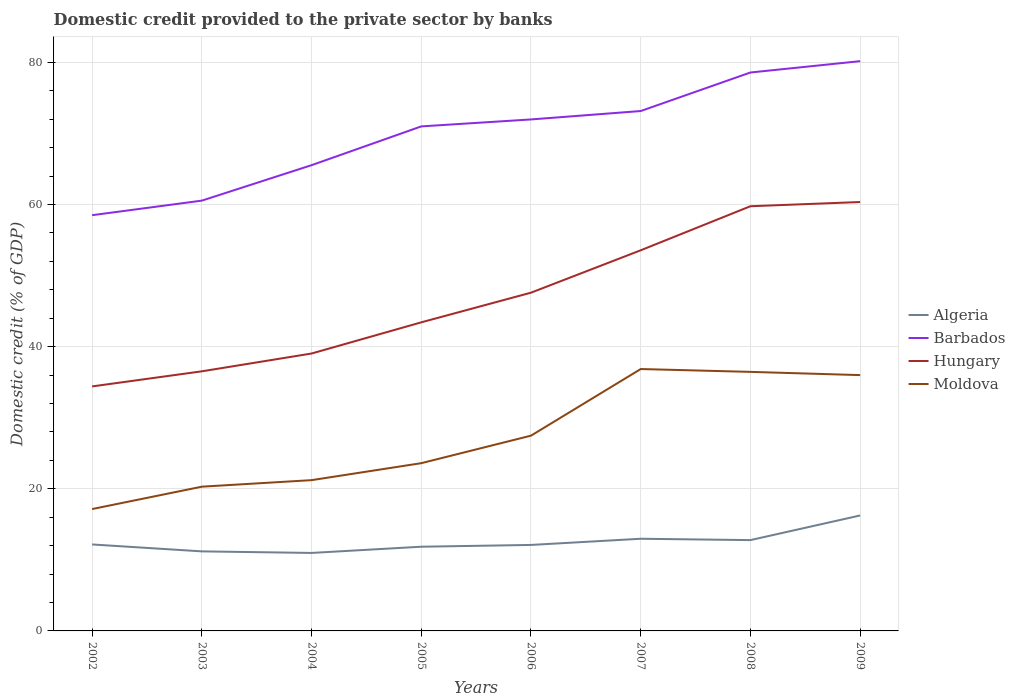How many different coloured lines are there?
Make the answer very short. 4. Across all years, what is the maximum domestic credit provided to the private sector by banks in Barbados?
Keep it short and to the point. 58.49. What is the total domestic credit provided to the private sector by banks in Algeria in the graph?
Your answer should be compact. 0.97. What is the difference between the highest and the second highest domestic credit provided to the private sector by banks in Hungary?
Offer a terse response. 25.94. How many years are there in the graph?
Ensure brevity in your answer.  8. What is the difference between two consecutive major ticks on the Y-axis?
Your answer should be very brief. 20. What is the title of the graph?
Ensure brevity in your answer.  Domestic credit provided to the private sector by banks. Does "Croatia" appear as one of the legend labels in the graph?
Ensure brevity in your answer.  No. What is the label or title of the Y-axis?
Your response must be concise. Domestic credit (% of GDP). What is the Domestic credit (% of GDP) of Algeria in 2002?
Your answer should be very brief. 12.17. What is the Domestic credit (% of GDP) of Barbados in 2002?
Offer a very short reply. 58.49. What is the Domestic credit (% of GDP) of Hungary in 2002?
Your answer should be compact. 34.4. What is the Domestic credit (% of GDP) in Moldova in 2002?
Ensure brevity in your answer.  17.15. What is the Domestic credit (% of GDP) of Algeria in 2003?
Give a very brief answer. 11.19. What is the Domestic credit (% of GDP) of Barbados in 2003?
Your answer should be compact. 60.54. What is the Domestic credit (% of GDP) in Hungary in 2003?
Your answer should be very brief. 36.52. What is the Domestic credit (% of GDP) of Moldova in 2003?
Ensure brevity in your answer.  20.29. What is the Domestic credit (% of GDP) in Algeria in 2004?
Make the answer very short. 10.97. What is the Domestic credit (% of GDP) of Barbados in 2004?
Your response must be concise. 65.53. What is the Domestic credit (% of GDP) of Hungary in 2004?
Your answer should be compact. 39.03. What is the Domestic credit (% of GDP) of Moldova in 2004?
Your answer should be compact. 21.21. What is the Domestic credit (% of GDP) in Algeria in 2005?
Your answer should be compact. 11.85. What is the Domestic credit (% of GDP) in Barbados in 2005?
Your answer should be compact. 70.98. What is the Domestic credit (% of GDP) in Hungary in 2005?
Your answer should be compact. 43.42. What is the Domestic credit (% of GDP) in Moldova in 2005?
Your answer should be compact. 23.6. What is the Domestic credit (% of GDP) in Algeria in 2006?
Provide a succinct answer. 12.1. What is the Domestic credit (% of GDP) of Barbados in 2006?
Provide a succinct answer. 71.96. What is the Domestic credit (% of GDP) of Hungary in 2006?
Provide a short and direct response. 47.59. What is the Domestic credit (% of GDP) in Moldova in 2006?
Provide a succinct answer. 27.47. What is the Domestic credit (% of GDP) in Algeria in 2007?
Your answer should be compact. 12.97. What is the Domestic credit (% of GDP) in Barbados in 2007?
Make the answer very short. 73.15. What is the Domestic credit (% of GDP) of Hungary in 2007?
Give a very brief answer. 53.55. What is the Domestic credit (% of GDP) of Moldova in 2007?
Offer a very short reply. 36.85. What is the Domestic credit (% of GDP) of Algeria in 2008?
Keep it short and to the point. 12.78. What is the Domestic credit (% of GDP) of Barbados in 2008?
Ensure brevity in your answer.  78.57. What is the Domestic credit (% of GDP) of Hungary in 2008?
Your answer should be very brief. 59.75. What is the Domestic credit (% of GDP) of Moldova in 2008?
Keep it short and to the point. 36.45. What is the Domestic credit (% of GDP) in Algeria in 2009?
Provide a short and direct response. 16.25. What is the Domestic credit (% of GDP) in Barbados in 2009?
Ensure brevity in your answer.  80.16. What is the Domestic credit (% of GDP) of Hungary in 2009?
Keep it short and to the point. 60.34. What is the Domestic credit (% of GDP) in Moldova in 2009?
Provide a succinct answer. 35.99. Across all years, what is the maximum Domestic credit (% of GDP) of Algeria?
Offer a terse response. 16.25. Across all years, what is the maximum Domestic credit (% of GDP) of Barbados?
Give a very brief answer. 80.16. Across all years, what is the maximum Domestic credit (% of GDP) in Hungary?
Provide a succinct answer. 60.34. Across all years, what is the maximum Domestic credit (% of GDP) of Moldova?
Ensure brevity in your answer.  36.85. Across all years, what is the minimum Domestic credit (% of GDP) of Algeria?
Your answer should be very brief. 10.97. Across all years, what is the minimum Domestic credit (% of GDP) of Barbados?
Offer a very short reply. 58.49. Across all years, what is the minimum Domestic credit (% of GDP) in Hungary?
Your answer should be compact. 34.4. Across all years, what is the minimum Domestic credit (% of GDP) in Moldova?
Your answer should be compact. 17.15. What is the total Domestic credit (% of GDP) in Algeria in the graph?
Your answer should be compact. 100.26. What is the total Domestic credit (% of GDP) of Barbados in the graph?
Ensure brevity in your answer.  559.38. What is the total Domestic credit (% of GDP) of Hungary in the graph?
Provide a succinct answer. 374.61. What is the total Domestic credit (% of GDP) in Moldova in the graph?
Your response must be concise. 219.01. What is the difference between the Domestic credit (% of GDP) of Algeria in 2002 and that in 2003?
Offer a very short reply. 0.97. What is the difference between the Domestic credit (% of GDP) of Barbados in 2002 and that in 2003?
Your response must be concise. -2.05. What is the difference between the Domestic credit (% of GDP) of Hungary in 2002 and that in 2003?
Provide a succinct answer. -2.12. What is the difference between the Domestic credit (% of GDP) in Moldova in 2002 and that in 2003?
Provide a short and direct response. -3.15. What is the difference between the Domestic credit (% of GDP) in Algeria in 2002 and that in 2004?
Your answer should be very brief. 1.19. What is the difference between the Domestic credit (% of GDP) of Barbados in 2002 and that in 2004?
Provide a short and direct response. -7.04. What is the difference between the Domestic credit (% of GDP) of Hungary in 2002 and that in 2004?
Offer a very short reply. -4.63. What is the difference between the Domestic credit (% of GDP) in Moldova in 2002 and that in 2004?
Your answer should be very brief. -4.07. What is the difference between the Domestic credit (% of GDP) in Algeria in 2002 and that in 2005?
Your response must be concise. 0.32. What is the difference between the Domestic credit (% of GDP) in Barbados in 2002 and that in 2005?
Keep it short and to the point. -12.49. What is the difference between the Domestic credit (% of GDP) of Hungary in 2002 and that in 2005?
Make the answer very short. -9.02. What is the difference between the Domestic credit (% of GDP) of Moldova in 2002 and that in 2005?
Keep it short and to the point. -6.46. What is the difference between the Domestic credit (% of GDP) of Algeria in 2002 and that in 2006?
Offer a very short reply. 0.07. What is the difference between the Domestic credit (% of GDP) of Barbados in 2002 and that in 2006?
Your answer should be compact. -13.47. What is the difference between the Domestic credit (% of GDP) in Hungary in 2002 and that in 2006?
Your response must be concise. -13.19. What is the difference between the Domestic credit (% of GDP) in Moldova in 2002 and that in 2006?
Provide a succinct answer. -10.33. What is the difference between the Domestic credit (% of GDP) in Algeria in 2002 and that in 2007?
Offer a terse response. -0.8. What is the difference between the Domestic credit (% of GDP) in Barbados in 2002 and that in 2007?
Make the answer very short. -14.65. What is the difference between the Domestic credit (% of GDP) in Hungary in 2002 and that in 2007?
Your answer should be very brief. -19.15. What is the difference between the Domestic credit (% of GDP) in Moldova in 2002 and that in 2007?
Offer a terse response. -19.7. What is the difference between the Domestic credit (% of GDP) of Algeria in 2002 and that in 2008?
Offer a very short reply. -0.61. What is the difference between the Domestic credit (% of GDP) of Barbados in 2002 and that in 2008?
Your answer should be very brief. -20.08. What is the difference between the Domestic credit (% of GDP) in Hungary in 2002 and that in 2008?
Offer a terse response. -25.35. What is the difference between the Domestic credit (% of GDP) of Moldova in 2002 and that in 2008?
Offer a very short reply. -19.3. What is the difference between the Domestic credit (% of GDP) in Algeria in 2002 and that in 2009?
Keep it short and to the point. -4.08. What is the difference between the Domestic credit (% of GDP) of Barbados in 2002 and that in 2009?
Give a very brief answer. -21.67. What is the difference between the Domestic credit (% of GDP) of Hungary in 2002 and that in 2009?
Provide a succinct answer. -25.94. What is the difference between the Domestic credit (% of GDP) in Moldova in 2002 and that in 2009?
Your answer should be very brief. -18.84. What is the difference between the Domestic credit (% of GDP) in Algeria in 2003 and that in 2004?
Make the answer very short. 0.22. What is the difference between the Domestic credit (% of GDP) of Barbados in 2003 and that in 2004?
Ensure brevity in your answer.  -4.99. What is the difference between the Domestic credit (% of GDP) in Hungary in 2003 and that in 2004?
Your answer should be compact. -2.5. What is the difference between the Domestic credit (% of GDP) in Moldova in 2003 and that in 2004?
Your answer should be very brief. -0.92. What is the difference between the Domestic credit (% of GDP) of Algeria in 2003 and that in 2005?
Make the answer very short. -0.66. What is the difference between the Domestic credit (% of GDP) of Barbados in 2003 and that in 2005?
Ensure brevity in your answer.  -10.44. What is the difference between the Domestic credit (% of GDP) of Hungary in 2003 and that in 2005?
Your answer should be very brief. -6.89. What is the difference between the Domestic credit (% of GDP) of Moldova in 2003 and that in 2005?
Give a very brief answer. -3.31. What is the difference between the Domestic credit (% of GDP) in Algeria in 2003 and that in 2006?
Your response must be concise. -0.91. What is the difference between the Domestic credit (% of GDP) in Barbados in 2003 and that in 2006?
Make the answer very short. -11.42. What is the difference between the Domestic credit (% of GDP) of Hungary in 2003 and that in 2006?
Provide a short and direct response. -11.07. What is the difference between the Domestic credit (% of GDP) of Moldova in 2003 and that in 2006?
Your answer should be compact. -7.18. What is the difference between the Domestic credit (% of GDP) of Algeria in 2003 and that in 2007?
Your response must be concise. -1.78. What is the difference between the Domestic credit (% of GDP) of Barbados in 2003 and that in 2007?
Keep it short and to the point. -12.61. What is the difference between the Domestic credit (% of GDP) of Hungary in 2003 and that in 2007?
Offer a very short reply. -17.03. What is the difference between the Domestic credit (% of GDP) in Moldova in 2003 and that in 2007?
Your answer should be very brief. -16.55. What is the difference between the Domestic credit (% of GDP) of Algeria in 2003 and that in 2008?
Your answer should be very brief. -1.59. What is the difference between the Domestic credit (% of GDP) in Barbados in 2003 and that in 2008?
Make the answer very short. -18.03. What is the difference between the Domestic credit (% of GDP) in Hungary in 2003 and that in 2008?
Keep it short and to the point. -23.23. What is the difference between the Domestic credit (% of GDP) of Moldova in 2003 and that in 2008?
Your answer should be very brief. -16.15. What is the difference between the Domestic credit (% of GDP) in Algeria in 2003 and that in 2009?
Keep it short and to the point. -5.05. What is the difference between the Domestic credit (% of GDP) of Barbados in 2003 and that in 2009?
Offer a very short reply. -19.62. What is the difference between the Domestic credit (% of GDP) in Hungary in 2003 and that in 2009?
Offer a terse response. -23.82. What is the difference between the Domestic credit (% of GDP) of Moldova in 2003 and that in 2009?
Make the answer very short. -15.7. What is the difference between the Domestic credit (% of GDP) in Algeria in 2004 and that in 2005?
Offer a very short reply. -0.87. What is the difference between the Domestic credit (% of GDP) of Barbados in 2004 and that in 2005?
Provide a succinct answer. -5.46. What is the difference between the Domestic credit (% of GDP) of Hungary in 2004 and that in 2005?
Offer a very short reply. -4.39. What is the difference between the Domestic credit (% of GDP) of Moldova in 2004 and that in 2005?
Keep it short and to the point. -2.39. What is the difference between the Domestic credit (% of GDP) in Algeria in 2004 and that in 2006?
Keep it short and to the point. -1.12. What is the difference between the Domestic credit (% of GDP) of Barbados in 2004 and that in 2006?
Your answer should be compact. -6.44. What is the difference between the Domestic credit (% of GDP) of Hungary in 2004 and that in 2006?
Make the answer very short. -8.56. What is the difference between the Domestic credit (% of GDP) in Moldova in 2004 and that in 2006?
Provide a succinct answer. -6.26. What is the difference between the Domestic credit (% of GDP) in Algeria in 2004 and that in 2007?
Your response must be concise. -2. What is the difference between the Domestic credit (% of GDP) of Barbados in 2004 and that in 2007?
Your response must be concise. -7.62. What is the difference between the Domestic credit (% of GDP) in Hungary in 2004 and that in 2007?
Keep it short and to the point. -14.52. What is the difference between the Domestic credit (% of GDP) in Moldova in 2004 and that in 2007?
Ensure brevity in your answer.  -15.63. What is the difference between the Domestic credit (% of GDP) of Algeria in 2004 and that in 2008?
Offer a terse response. -1.8. What is the difference between the Domestic credit (% of GDP) of Barbados in 2004 and that in 2008?
Your response must be concise. -13.04. What is the difference between the Domestic credit (% of GDP) in Hungary in 2004 and that in 2008?
Offer a very short reply. -20.72. What is the difference between the Domestic credit (% of GDP) of Moldova in 2004 and that in 2008?
Your response must be concise. -15.23. What is the difference between the Domestic credit (% of GDP) of Algeria in 2004 and that in 2009?
Offer a terse response. -5.27. What is the difference between the Domestic credit (% of GDP) in Barbados in 2004 and that in 2009?
Provide a short and direct response. -14.63. What is the difference between the Domestic credit (% of GDP) in Hungary in 2004 and that in 2009?
Make the answer very short. -21.31. What is the difference between the Domestic credit (% of GDP) in Moldova in 2004 and that in 2009?
Your answer should be compact. -14.78. What is the difference between the Domestic credit (% of GDP) of Algeria in 2005 and that in 2006?
Make the answer very short. -0.25. What is the difference between the Domestic credit (% of GDP) of Barbados in 2005 and that in 2006?
Make the answer very short. -0.98. What is the difference between the Domestic credit (% of GDP) in Hungary in 2005 and that in 2006?
Your answer should be very brief. -4.17. What is the difference between the Domestic credit (% of GDP) in Moldova in 2005 and that in 2006?
Your answer should be very brief. -3.87. What is the difference between the Domestic credit (% of GDP) of Algeria in 2005 and that in 2007?
Your response must be concise. -1.12. What is the difference between the Domestic credit (% of GDP) in Barbados in 2005 and that in 2007?
Offer a terse response. -2.16. What is the difference between the Domestic credit (% of GDP) in Hungary in 2005 and that in 2007?
Offer a very short reply. -10.14. What is the difference between the Domestic credit (% of GDP) in Moldova in 2005 and that in 2007?
Make the answer very short. -13.24. What is the difference between the Domestic credit (% of GDP) of Algeria in 2005 and that in 2008?
Offer a very short reply. -0.93. What is the difference between the Domestic credit (% of GDP) in Barbados in 2005 and that in 2008?
Your answer should be compact. -7.58. What is the difference between the Domestic credit (% of GDP) of Hungary in 2005 and that in 2008?
Your response must be concise. -16.33. What is the difference between the Domestic credit (% of GDP) in Moldova in 2005 and that in 2008?
Make the answer very short. -12.85. What is the difference between the Domestic credit (% of GDP) of Algeria in 2005 and that in 2009?
Your answer should be very brief. -4.4. What is the difference between the Domestic credit (% of GDP) of Barbados in 2005 and that in 2009?
Your response must be concise. -9.18. What is the difference between the Domestic credit (% of GDP) of Hungary in 2005 and that in 2009?
Ensure brevity in your answer.  -16.93. What is the difference between the Domestic credit (% of GDP) of Moldova in 2005 and that in 2009?
Provide a succinct answer. -12.39. What is the difference between the Domestic credit (% of GDP) in Algeria in 2006 and that in 2007?
Make the answer very short. -0.87. What is the difference between the Domestic credit (% of GDP) of Barbados in 2006 and that in 2007?
Provide a short and direct response. -1.18. What is the difference between the Domestic credit (% of GDP) in Hungary in 2006 and that in 2007?
Your answer should be compact. -5.96. What is the difference between the Domestic credit (% of GDP) of Moldova in 2006 and that in 2007?
Keep it short and to the point. -9.37. What is the difference between the Domestic credit (% of GDP) of Algeria in 2006 and that in 2008?
Keep it short and to the point. -0.68. What is the difference between the Domestic credit (% of GDP) of Barbados in 2006 and that in 2008?
Keep it short and to the point. -6.6. What is the difference between the Domestic credit (% of GDP) of Hungary in 2006 and that in 2008?
Ensure brevity in your answer.  -12.16. What is the difference between the Domestic credit (% of GDP) in Moldova in 2006 and that in 2008?
Ensure brevity in your answer.  -8.97. What is the difference between the Domestic credit (% of GDP) in Algeria in 2006 and that in 2009?
Keep it short and to the point. -4.15. What is the difference between the Domestic credit (% of GDP) of Barbados in 2006 and that in 2009?
Provide a succinct answer. -8.2. What is the difference between the Domestic credit (% of GDP) in Hungary in 2006 and that in 2009?
Offer a very short reply. -12.75. What is the difference between the Domestic credit (% of GDP) of Moldova in 2006 and that in 2009?
Offer a terse response. -8.52. What is the difference between the Domestic credit (% of GDP) in Algeria in 2007 and that in 2008?
Your answer should be very brief. 0.19. What is the difference between the Domestic credit (% of GDP) in Barbados in 2007 and that in 2008?
Provide a succinct answer. -5.42. What is the difference between the Domestic credit (% of GDP) in Hungary in 2007 and that in 2008?
Give a very brief answer. -6.2. What is the difference between the Domestic credit (% of GDP) in Moldova in 2007 and that in 2008?
Ensure brevity in your answer.  0.4. What is the difference between the Domestic credit (% of GDP) in Algeria in 2007 and that in 2009?
Make the answer very short. -3.28. What is the difference between the Domestic credit (% of GDP) in Barbados in 2007 and that in 2009?
Provide a short and direct response. -7.02. What is the difference between the Domestic credit (% of GDP) of Hungary in 2007 and that in 2009?
Your answer should be compact. -6.79. What is the difference between the Domestic credit (% of GDP) of Moldova in 2007 and that in 2009?
Give a very brief answer. 0.85. What is the difference between the Domestic credit (% of GDP) of Algeria in 2008 and that in 2009?
Offer a terse response. -3.47. What is the difference between the Domestic credit (% of GDP) in Barbados in 2008 and that in 2009?
Offer a very short reply. -1.59. What is the difference between the Domestic credit (% of GDP) in Hungary in 2008 and that in 2009?
Offer a very short reply. -0.59. What is the difference between the Domestic credit (% of GDP) in Moldova in 2008 and that in 2009?
Provide a succinct answer. 0.46. What is the difference between the Domestic credit (% of GDP) in Algeria in 2002 and the Domestic credit (% of GDP) in Barbados in 2003?
Give a very brief answer. -48.37. What is the difference between the Domestic credit (% of GDP) of Algeria in 2002 and the Domestic credit (% of GDP) of Hungary in 2003?
Your response must be concise. -24.36. What is the difference between the Domestic credit (% of GDP) in Algeria in 2002 and the Domestic credit (% of GDP) in Moldova in 2003?
Your response must be concise. -8.13. What is the difference between the Domestic credit (% of GDP) in Barbados in 2002 and the Domestic credit (% of GDP) in Hungary in 2003?
Keep it short and to the point. 21.97. What is the difference between the Domestic credit (% of GDP) of Barbados in 2002 and the Domestic credit (% of GDP) of Moldova in 2003?
Your response must be concise. 38.2. What is the difference between the Domestic credit (% of GDP) in Hungary in 2002 and the Domestic credit (% of GDP) in Moldova in 2003?
Make the answer very short. 14.11. What is the difference between the Domestic credit (% of GDP) of Algeria in 2002 and the Domestic credit (% of GDP) of Barbados in 2004?
Offer a terse response. -53.36. What is the difference between the Domestic credit (% of GDP) in Algeria in 2002 and the Domestic credit (% of GDP) in Hungary in 2004?
Keep it short and to the point. -26.86. What is the difference between the Domestic credit (% of GDP) of Algeria in 2002 and the Domestic credit (% of GDP) of Moldova in 2004?
Make the answer very short. -9.05. What is the difference between the Domestic credit (% of GDP) of Barbados in 2002 and the Domestic credit (% of GDP) of Hungary in 2004?
Provide a short and direct response. 19.46. What is the difference between the Domestic credit (% of GDP) of Barbados in 2002 and the Domestic credit (% of GDP) of Moldova in 2004?
Give a very brief answer. 37.28. What is the difference between the Domestic credit (% of GDP) of Hungary in 2002 and the Domestic credit (% of GDP) of Moldova in 2004?
Your answer should be compact. 13.19. What is the difference between the Domestic credit (% of GDP) of Algeria in 2002 and the Domestic credit (% of GDP) of Barbados in 2005?
Give a very brief answer. -58.82. What is the difference between the Domestic credit (% of GDP) in Algeria in 2002 and the Domestic credit (% of GDP) in Hungary in 2005?
Ensure brevity in your answer.  -31.25. What is the difference between the Domestic credit (% of GDP) in Algeria in 2002 and the Domestic credit (% of GDP) in Moldova in 2005?
Your answer should be very brief. -11.44. What is the difference between the Domestic credit (% of GDP) of Barbados in 2002 and the Domestic credit (% of GDP) of Hungary in 2005?
Offer a very short reply. 15.07. What is the difference between the Domestic credit (% of GDP) of Barbados in 2002 and the Domestic credit (% of GDP) of Moldova in 2005?
Offer a terse response. 34.89. What is the difference between the Domestic credit (% of GDP) of Hungary in 2002 and the Domestic credit (% of GDP) of Moldova in 2005?
Your response must be concise. 10.8. What is the difference between the Domestic credit (% of GDP) in Algeria in 2002 and the Domestic credit (% of GDP) in Barbados in 2006?
Your response must be concise. -59.8. What is the difference between the Domestic credit (% of GDP) of Algeria in 2002 and the Domestic credit (% of GDP) of Hungary in 2006?
Offer a very short reply. -35.42. What is the difference between the Domestic credit (% of GDP) of Algeria in 2002 and the Domestic credit (% of GDP) of Moldova in 2006?
Keep it short and to the point. -15.31. What is the difference between the Domestic credit (% of GDP) in Barbados in 2002 and the Domestic credit (% of GDP) in Hungary in 2006?
Provide a succinct answer. 10.9. What is the difference between the Domestic credit (% of GDP) in Barbados in 2002 and the Domestic credit (% of GDP) in Moldova in 2006?
Give a very brief answer. 31.02. What is the difference between the Domestic credit (% of GDP) of Hungary in 2002 and the Domestic credit (% of GDP) of Moldova in 2006?
Ensure brevity in your answer.  6.93. What is the difference between the Domestic credit (% of GDP) in Algeria in 2002 and the Domestic credit (% of GDP) in Barbados in 2007?
Make the answer very short. -60.98. What is the difference between the Domestic credit (% of GDP) of Algeria in 2002 and the Domestic credit (% of GDP) of Hungary in 2007?
Your answer should be compact. -41.39. What is the difference between the Domestic credit (% of GDP) in Algeria in 2002 and the Domestic credit (% of GDP) in Moldova in 2007?
Your answer should be very brief. -24.68. What is the difference between the Domestic credit (% of GDP) in Barbados in 2002 and the Domestic credit (% of GDP) in Hungary in 2007?
Ensure brevity in your answer.  4.94. What is the difference between the Domestic credit (% of GDP) in Barbados in 2002 and the Domestic credit (% of GDP) in Moldova in 2007?
Offer a terse response. 21.65. What is the difference between the Domestic credit (% of GDP) in Hungary in 2002 and the Domestic credit (% of GDP) in Moldova in 2007?
Your answer should be very brief. -2.44. What is the difference between the Domestic credit (% of GDP) of Algeria in 2002 and the Domestic credit (% of GDP) of Barbados in 2008?
Your answer should be very brief. -66.4. What is the difference between the Domestic credit (% of GDP) in Algeria in 2002 and the Domestic credit (% of GDP) in Hungary in 2008?
Keep it short and to the point. -47.59. What is the difference between the Domestic credit (% of GDP) of Algeria in 2002 and the Domestic credit (% of GDP) of Moldova in 2008?
Offer a very short reply. -24.28. What is the difference between the Domestic credit (% of GDP) in Barbados in 2002 and the Domestic credit (% of GDP) in Hungary in 2008?
Your answer should be very brief. -1.26. What is the difference between the Domestic credit (% of GDP) of Barbados in 2002 and the Domestic credit (% of GDP) of Moldova in 2008?
Offer a terse response. 22.04. What is the difference between the Domestic credit (% of GDP) in Hungary in 2002 and the Domestic credit (% of GDP) in Moldova in 2008?
Provide a succinct answer. -2.05. What is the difference between the Domestic credit (% of GDP) of Algeria in 2002 and the Domestic credit (% of GDP) of Barbados in 2009?
Give a very brief answer. -68. What is the difference between the Domestic credit (% of GDP) of Algeria in 2002 and the Domestic credit (% of GDP) of Hungary in 2009?
Your response must be concise. -48.18. What is the difference between the Domestic credit (% of GDP) of Algeria in 2002 and the Domestic credit (% of GDP) of Moldova in 2009?
Ensure brevity in your answer.  -23.83. What is the difference between the Domestic credit (% of GDP) of Barbados in 2002 and the Domestic credit (% of GDP) of Hungary in 2009?
Keep it short and to the point. -1.85. What is the difference between the Domestic credit (% of GDP) of Barbados in 2002 and the Domestic credit (% of GDP) of Moldova in 2009?
Give a very brief answer. 22.5. What is the difference between the Domestic credit (% of GDP) of Hungary in 2002 and the Domestic credit (% of GDP) of Moldova in 2009?
Provide a succinct answer. -1.59. What is the difference between the Domestic credit (% of GDP) of Algeria in 2003 and the Domestic credit (% of GDP) of Barbados in 2004?
Your answer should be very brief. -54.34. What is the difference between the Domestic credit (% of GDP) in Algeria in 2003 and the Domestic credit (% of GDP) in Hungary in 2004?
Your answer should be very brief. -27.84. What is the difference between the Domestic credit (% of GDP) in Algeria in 2003 and the Domestic credit (% of GDP) in Moldova in 2004?
Your answer should be compact. -10.02. What is the difference between the Domestic credit (% of GDP) of Barbados in 2003 and the Domestic credit (% of GDP) of Hungary in 2004?
Offer a very short reply. 21.51. What is the difference between the Domestic credit (% of GDP) of Barbados in 2003 and the Domestic credit (% of GDP) of Moldova in 2004?
Offer a very short reply. 39.33. What is the difference between the Domestic credit (% of GDP) of Hungary in 2003 and the Domestic credit (% of GDP) of Moldova in 2004?
Offer a terse response. 15.31. What is the difference between the Domestic credit (% of GDP) in Algeria in 2003 and the Domestic credit (% of GDP) in Barbados in 2005?
Provide a short and direct response. -59.79. What is the difference between the Domestic credit (% of GDP) in Algeria in 2003 and the Domestic credit (% of GDP) in Hungary in 2005?
Make the answer very short. -32.23. What is the difference between the Domestic credit (% of GDP) in Algeria in 2003 and the Domestic credit (% of GDP) in Moldova in 2005?
Offer a terse response. -12.41. What is the difference between the Domestic credit (% of GDP) of Barbados in 2003 and the Domestic credit (% of GDP) of Hungary in 2005?
Offer a terse response. 17.12. What is the difference between the Domestic credit (% of GDP) of Barbados in 2003 and the Domestic credit (% of GDP) of Moldova in 2005?
Your response must be concise. 36.94. What is the difference between the Domestic credit (% of GDP) of Hungary in 2003 and the Domestic credit (% of GDP) of Moldova in 2005?
Make the answer very short. 12.92. What is the difference between the Domestic credit (% of GDP) in Algeria in 2003 and the Domestic credit (% of GDP) in Barbados in 2006?
Offer a terse response. -60.77. What is the difference between the Domestic credit (% of GDP) of Algeria in 2003 and the Domestic credit (% of GDP) of Hungary in 2006?
Provide a succinct answer. -36.4. What is the difference between the Domestic credit (% of GDP) of Algeria in 2003 and the Domestic credit (% of GDP) of Moldova in 2006?
Your response must be concise. -16.28. What is the difference between the Domestic credit (% of GDP) of Barbados in 2003 and the Domestic credit (% of GDP) of Hungary in 2006?
Provide a succinct answer. 12.95. What is the difference between the Domestic credit (% of GDP) of Barbados in 2003 and the Domestic credit (% of GDP) of Moldova in 2006?
Your answer should be very brief. 33.07. What is the difference between the Domestic credit (% of GDP) of Hungary in 2003 and the Domestic credit (% of GDP) of Moldova in 2006?
Give a very brief answer. 9.05. What is the difference between the Domestic credit (% of GDP) of Algeria in 2003 and the Domestic credit (% of GDP) of Barbados in 2007?
Ensure brevity in your answer.  -61.95. What is the difference between the Domestic credit (% of GDP) of Algeria in 2003 and the Domestic credit (% of GDP) of Hungary in 2007?
Provide a succinct answer. -42.36. What is the difference between the Domestic credit (% of GDP) in Algeria in 2003 and the Domestic credit (% of GDP) in Moldova in 2007?
Provide a short and direct response. -25.65. What is the difference between the Domestic credit (% of GDP) of Barbados in 2003 and the Domestic credit (% of GDP) of Hungary in 2007?
Keep it short and to the point. 6.99. What is the difference between the Domestic credit (% of GDP) in Barbados in 2003 and the Domestic credit (% of GDP) in Moldova in 2007?
Keep it short and to the point. 23.69. What is the difference between the Domestic credit (% of GDP) of Hungary in 2003 and the Domestic credit (% of GDP) of Moldova in 2007?
Your answer should be very brief. -0.32. What is the difference between the Domestic credit (% of GDP) of Algeria in 2003 and the Domestic credit (% of GDP) of Barbados in 2008?
Give a very brief answer. -67.38. What is the difference between the Domestic credit (% of GDP) of Algeria in 2003 and the Domestic credit (% of GDP) of Hungary in 2008?
Provide a succinct answer. -48.56. What is the difference between the Domestic credit (% of GDP) in Algeria in 2003 and the Domestic credit (% of GDP) in Moldova in 2008?
Provide a short and direct response. -25.26. What is the difference between the Domestic credit (% of GDP) of Barbados in 2003 and the Domestic credit (% of GDP) of Hungary in 2008?
Your response must be concise. 0.79. What is the difference between the Domestic credit (% of GDP) in Barbados in 2003 and the Domestic credit (% of GDP) in Moldova in 2008?
Provide a succinct answer. 24.09. What is the difference between the Domestic credit (% of GDP) in Hungary in 2003 and the Domestic credit (% of GDP) in Moldova in 2008?
Keep it short and to the point. 0.08. What is the difference between the Domestic credit (% of GDP) in Algeria in 2003 and the Domestic credit (% of GDP) in Barbados in 2009?
Offer a terse response. -68.97. What is the difference between the Domestic credit (% of GDP) in Algeria in 2003 and the Domestic credit (% of GDP) in Hungary in 2009?
Provide a short and direct response. -49.15. What is the difference between the Domestic credit (% of GDP) of Algeria in 2003 and the Domestic credit (% of GDP) of Moldova in 2009?
Give a very brief answer. -24.8. What is the difference between the Domestic credit (% of GDP) of Barbados in 2003 and the Domestic credit (% of GDP) of Hungary in 2009?
Make the answer very short. 0.2. What is the difference between the Domestic credit (% of GDP) in Barbados in 2003 and the Domestic credit (% of GDP) in Moldova in 2009?
Your response must be concise. 24.55. What is the difference between the Domestic credit (% of GDP) of Hungary in 2003 and the Domestic credit (% of GDP) of Moldova in 2009?
Your answer should be very brief. 0.53. What is the difference between the Domestic credit (% of GDP) of Algeria in 2004 and the Domestic credit (% of GDP) of Barbados in 2005?
Your answer should be compact. -60.01. What is the difference between the Domestic credit (% of GDP) in Algeria in 2004 and the Domestic credit (% of GDP) in Hungary in 2005?
Your response must be concise. -32.44. What is the difference between the Domestic credit (% of GDP) of Algeria in 2004 and the Domestic credit (% of GDP) of Moldova in 2005?
Your answer should be very brief. -12.63. What is the difference between the Domestic credit (% of GDP) of Barbados in 2004 and the Domestic credit (% of GDP) of Hungary in 2005?
Keep it short and to the point. 22.11. What is the difference between the Domestic credit (% of GDP) in Barbados in 2004 and the Domestic credit (% of GDP) in Moldova in 2005?
Offer a terse response. 41.93. What is the difference between the Domestic credit (% of GDP) of Hungary in 2004 and the Domestic credit (% of GDP) of Moldova in 2005?
Provide a succinct answer. 15.43. What is the difference between the Domestic credit (% of GDP) in Algeria in 2004 and the Domestic credit (% of GDP) in Barbados in 2006?
Provide a succinct answer. -60.99. What is the difference between the Domestic credit (% of GDP) in Algeria in 2004 and the Domestic credit (% of GDP) in Hungary in 2006?
Give a very brief answer. -36.62. What is the difference between the Domestic credit (% of GDP) in Algeria in 2004 and the Domestic credit (% of GDP) in Moldova in 2006?
Keep it short and to the point. -16.5. What is the difference between the Domestic credit (% of GDP) in Barbados in 2004 and the Domestic credit (% of GDP) in Hungary in 2006?
Your answer should be compact. 17.94. What is the difference between the Domestic credit (% of GDP) of Barbados in 2004 and the Domestic credit (% of GDP) of Moldova in 2006?
Your answer should be compact. 38.05. What is the difference between the Domestic credit (% of GDP) in Hungary in 2004 and the Domestic credit (% of GDP) in Moldova in 2006?
Keep it short and to the point. 11.56. What is the difference between the Domestic credit (% of GDP) in Algeria in 2004 and the Domestic credit (% of GDP) in Barbados in 2007?
Offer a terse response. -62.17. What is the difference between the Domestic credit (% of GDP) in Algeria in 2004 and the Domestic credit (% of GDP) in Hungary in 2007?
Your answer should be compact. -42.58. What is the difference between the Domestic credit (% of GDP) of Algeria in 2004 and the Domestic credit (% of GDP) of Moldova in 2007?
Provide a short and direct response. -25.87. What is the difference between the Domestic credit (% of GDP) in Barbados in 2004 and the Domestic credit (% of GDP) in Hungary in 2007?
Offer a very short reply. 11.98. What is the difference between the Domestic credit (% of GDP) of Barbados in 2004 and the Domestic credit (% of GDP) of Moldova in 2007?
Offer a very short reply. 28.68. What is the difference between the Domestic credit (% of GDP) in Hungary in 2004 and the Domestic credit (% of GDP) in Moldova in 2007?
Your answer should be compact. 2.18. What is the difference between the Domestic credit (% of GDP) of Algeria in 2004 and the Domestic credit (% of GDP) of Barbados in 2008?
Provide a succinct answer. -67.59. What is the difference between the Domestic credit (% of GDP) in Algeria in 2004 and the Domestic credit (% of GDP) in Hungary in 2008?
Ensure brevity in your answer.  -48.78. What is the difference between the Domestic credit (% of GDP) in Algeria in 2004 and the Domestic credit (% of GDP) in Moldova in 2008?
Provide a short and direct response. -25.47. What is the difference between the Domestic credit (% of GDP) of Barbados in 2004 and the Domestic credit (% of GDP) of Hungary in 2008?
Make the answer very short. 5.78. What is the difference between the Domestic credit (% of GDP) in Barbados in 2004 and the Domestic credit (% of GDP) in Moldova in 2008?
Offer a terse response. 29.08. What is the difference between the Domestic credit (% of GDP) of Hungary in 2004 and the Domestic credit (% of GDP) of Moldova in 2008?
Provide a succinct answer. 2.58. What is the difference between the Domestic credit (% of GDP) in Algeria in 2004 and the Domestic credit (% of GDP) in Barbados in 2009?
Your response must be concise. -69.19. What is the difference between the Domestic credit (% of GDP) of Algeria in 2004 and the Domestic credit (% of GDP) of Hungary in 2009?
Keep it short and to the point. -49.37. What is the difference between the Domestic credit (% of GDP) of Algeria in 2004 and the Domestic credit (% of GDP) of Moldova in 2009?
Provide a succinct answer. -25.02. What is the difference between the Domestic credit (% of GDP) of Barbados in 2004 and the Domestic credit (% of GDP) of Hungary in 2009?
Keep it short and to the point. 5.18. What is the difference between the Domestic credit (% of GDP) of Barbados in 2004 and the Domestic credit (% of GDP) of Moldova in 2009?
Your answer should be compact. 29.54. What is the difference between the Domestic credit (% of GDP) in Hungary in 2004 and the Domestic credit (% of GDP) in Moldova in 2009?
Offer a terse response. 3.04. What is the difference between the Domestic credit (% of GDP) in Algeria in 2005 and the Domestic credit (% of GDP) in Barbados in 2006?
Provide a short and direct response. -60.12. What is the difference between the Domestic credit (% of GDP) in Algeria in 2005 and the Domestic credit (% of GDP) in Hungary in 2006?
Your response must be concise. -35.74. What is the difference between the Domestic credit (% of GDP) of Algeria in 2005 and the Domestic credit (% of GDP) of Moldova in 2006?
Your answer should be very brief. -15.63. What is the difference between the Domestic credit (% of GDP) in Barbados in 2005 and the Domestic credit (% of GDP) in Hungary in 2006?
Your answer should be very brief. 23.39. What is the difference between the Domestic credit (% of GDP) in Barbados in 2005 and the Domestic credit (% of GDP) in Moldova in 2006?
Your response must be concise. 43.51. What is the difference between the Domestic credit (% of GDP) of Hungary in 2005 and the Domestic credit (% of GDP) of Moldova in 2006?
Give a very brief answer. 15.94. What is the difference between the Domestic credit (% of GDP) of Algeria in 2005 and the Domestic credit (% of GDP) of Barbados in 2007?
Provide a short and direct response. -61.3. What is the difference between the Domestic credit (% of GDP) of Algeria in 2005 and the Domestic credit (% of GDP) of Hungary in 2007?
Keep it short and to the point. -41.71. What is the difference between the Domestic credit (% of GDP) of Algeria in 2005 and the Domestic credit (% of GDP) of Moldova in 2007?
Your answer should be very brief. -25. What is the difference between the Domestic credit (% of GDP) in Barbados in 2005 and the Domestic credit (% of GDP) in Hungary in 2007?
Keep it short and to the point. 17.43. What is the difference between the Domestic credit (% of GDP) in Barbados in 2005 and the Domestic credit (% of GDP) in Moldova in 2007?
Keep it short and to the point. 34.14. What is the difference between the Domestic credit (% of GDP) of Hungary in 2005 and the Domestic credit (% of GDP) of Moldova in 2007?
Provide a succinct answer. 6.57. What is the difference between the Domestic credit (% of GDP) of Algeria in 2005 and the Domestic credit (% of GDP) of Barbados in 2008?
Offer a terse response. -66.72. What is the difference between the Domestic credit (% of GDP) of Algeria in 2005 and the Domestic credit (% of GDP) of Hungary in 2008?
Keep it short and to the point. -47.9. What is the difference between the Domestic credit (% of GDP) in Algeria in 2005 and the Domestic credit (% of GDP) in Moldova in 2008?
Offer a terse response. -24.6. What is the difference between the Domestic credit (% of GDP) in Barbados in 2005 and the Domestic credit (% of GDP) in Hungary in 2008?
Provide a succinct answer. 11.23. What is the difference between the Domestic credit (% of GDP) in Barbados in 2005 and the Domestic credit (% of GDP) in Moldova in 2008?
Provide a short and direct response. 34.54. What is the difference between the Domestic credit (% of GDP) in Hungary in 2005 and the Domestic credit (% of GDP) in Moldova in 2008?
Provide a short and direct response. 6.97. What is the difference between the Domestic credit (% of GDP) of Algeria in 2005 and the Domestic credit (% of GDP) of Barbados in 2009?
Your answer should be very brief. -68.31. What is the difference between the Domestic credit (% of GDP) in Algeria in 2005 and the Domestic credit (% of GDP) in Hungary in 2009?
Provide a short and direct response. -48.5. What is the difference between the Domestic credit (% of GDP) in Algeria in 2005 and the Domestic credit (% of GDP) in Moldova in 2009?
Keep it short and to the point. -24.14. What is the difference between the Domestic credit (% of GDP) of Barbados in 2005 and the Domestic credit (% of GDP) of Hungary in 2009?
Ensure brevity in your answer.  10.64. What is the difference between the Domestic credit (% of GDP) of Barbados in 2005 and the Domestic credit (% of GDP) of Moldova in 2009?
Provide a short and direct response. 34.99. What is the difference between the Domestic credit (% of GDP) in Hungary in 2005 and the Domestic credit (% of GDP) in Moldova in 2009?
Your answer should be compact. 7.43. What is the difference between the Domestic credit (% of GDP) in Algeria in 2006 and the Domestic credit (% of GDP) in Barbados in 2007?
Offer a very short reply. -61.05. What is the difference between the Domestic credit (% of GDP) in Algeria in 2006 and the Domestic credit (% of GDP) in Hungary in 2007?
Your response must be concise. -41.46. What is the difference between the Domestic credit (% of GDP) in Algeria in 2006 and the Domestic credit (% of GDP) in Moldova in 2007?
Ensure brevity in your answer.  -24.75. What is the difference between the Domestic credit (% of GDP) of Barbados in 2006 and the Domestic credit (% of GDP) of Hungary in 2007?
Your answer should be very brief. 18.41. What is the difference between the Domestic credit (% of GDP) of Barbados in 2006 and the Domestic credit (% of GDP) of Moldova in 2007?
Offer a very short reply. 35.12. What is the difference between the Domestic credit (% of GDP) of Hungary in 2006 and the Domestic credit (% of GDP) of Moldova in 2007?
Keep it short and to the point. 10.74. What is the difference between the Domestic credit (% of GDP) in Algeria in 2006 and the Domestic credit (% of GDP) in Barbados in 2008?
Your response must be concise. -66.47. What is the difference between the Domestic credit (% of GDP) in Algeria in 2006 and the Domestic credit (% of GDP) in Hungary in 2008?
Your answer should be very brief. -47.65. What is the difference between the Domestic credit (% of GDP) in Algeria in 2006 and the Domestic credit (% of GDP) in Moldova in 2008?
Offer a terse response. -24.35. What is the difference between the Domestic credit (% of GDP) of Barbados in 2006 and the Domestic credit (% of GDP) of Hungary in 2008?
Give a very brief answer. 12.21. What is the difference between the Domestic credit (% of GDP) of Barbados in 2006 and the Domestic credit (% of GDP) of Moldova in 2008?
Your answer should be very brief. 35.52. What is the difference between the Domestic credit (% of GDP) in Hungary in 2006 and the Domestic credit (% of GDP) in Moldova in 2008?
Provide a short and direct response. 11.14. What is the difference between the Domestic credit (% of GDP) in Algeria in 2006 and the Domestic credit (% of GDP) in Barbados in 2009?
Offer a terse response. -68.06. What is the difference between the Domestic credit (% of GDP) in Algeria in 2006 and the Domestic credit (% of GDP) in Hungary in 2009?
Your answer should be very brief. -48.25. What is the difference between the Domestic credit (% of GDP) of Algeria in 2006 and the Domestic credit (% of GDP) of Moldova in 2009?
Give a very brief answer. -23.89. What is the difference between the Domestic credit (% of GDP) of Barbados in 2006 and the Domestic credit (% of GDP) of Hungary in 2009?
Ensure brevity in your answer.  11.62. What is the difference between the Domestic credit (% of GDP) in Barbados in 2006 and the Domestic credit (% of GDP) in Moldova in 2009?
Your answer should be very brief. 35.97. What is the difference between the Domestic credit (% of GDP) in Hungary in 2006 and the Domestic credit (% of GDP) in Moldova in 2009?
Keep it short and to the point. 11.6. What is the difference between the Domestic credit (% of GDP) of Algeria in 2007 and the Domestic credit (% of GDP) of Barbados in 2008?
Provide a short and direct response. -65.6. What is the difference between the Domestic credit (% of GDP) in Algeria in 2007 and the Domestic credit (% of GDP) in Hungary in 2008?
Your answer should be compact. -46.78. What is the difference between the Domestic credit (% of GDP) in Algeria in 2007 and the Domestic credit (% of GDP) in Moldova in 2008?
Provide a short and direct response. -23.48. What is the difference between the Domestic credit (% of GDP) in Barbados in 2007 and the Domestic credit (% of GDP) in Hungary in 2008?
Provide a short and direct response. 13.39. What is the difference between the Domestic credit (% of GDP) in Barbados in 2007 and the Domestic credit (% of GDP) in Moldova in 2008?
Offer a terse response. 36.7. What is the difference between the Domestic credit (% of GDP) of Hungary in 2007 and the Domestic credit (% of GDP) of Moldova in 2008?
Provide a short and direct response. 17.11. What is the difference between the Domestic credit (% of GDP) in Algeria in 2007 and the Domestic credit (% of GDP) in Barbados in 2009?
Your answer should be very brief. -67.19. What is the difference between the Domestic credit (% of GDP) in Algeria in 2007 and the Domestic credit (% of GDP) in Hungary in 2009?
Your answer should be compact. -47.37. What is the difference between the Domestic credit (% of GDP) in Algeria in 2007 and the Domestic credit (% of GDP) in Moldova in 2009?
Your response must be concise. -23.02. What is the difference between the Domestic credit (% of GDP) in Barbados in 2007 and the Domestic credit (% of GDP) in Hungary in 2009?
Provide a succinct answer. 12.8. What is the difference between the Domestic credit (% of GDP) in Barbados in 2007 and the Domestic credit (% of GDP) in Moldova in 2009?
Your answer should be compact. 37.15. What is the difference between the Domestic credit (% of GDP) of Hungary in 2007 and the Domestic credit (% of GDP) of Moldova in 2009?
Keep it short and to the point. 17.56. What is the difference between the Domestic credit (% of GDP) of Algeria in 2008 and the Domestic credit (% of GDP) of Barbados in 2009?
Provide a succinct answer. -67.38. What is the difference between the Domestic credit (% of GDP) of Algeria in 2008 and the Domestic credit (% of GDP) of Hungary in 2009?
Keep it short and to the point. -47.57. What is the difference between the Domestic credit (% of GDP) of Algeria in 2008 and the Domestic credit (% of GDP) of Moldova in 2009?
Ensure brevity in your answer.  -23.21. What is the difference between the Domestic credit (% of GDP) in Barbados in 2008 and the Domestic credit (% of GDP) in Hungary in 2009?
Ensure brevity in your answer.  18.22. What is the difference between the Domestic credit (% of GDP) in Barbados in 2008 and the Domestic credit (% of GDP) in Moldova in 2009?
Your answer should be very brief. 42.58. What is the difference between the Domestic credit (% of GDP) in Hungary in 2008 and the Domestic credit (% of GDP) in Moldova in 2009?
Ensure brevity in your answer.  23.76. What is the average Domestic credit (% of GDP) of Algeria per year?
Keep it short and to the point. 12.53. What is the average Domestic credit (% of GDP) of Barbados per year?
Your response must be concise. 69.92. What is the average Domestic credit (% of GDP) in Hungary per year?
Offer a very short reply. 46.83. What is the average Domestic credit (% of GDP) in Moldova per year?
Provide a short and direct response. 27.38. In the year 2002, what is the difference between the Domestic credit (% of GDP) of Algeria and Domestic credit (% of GDP) of Barbados?
Your answer should be very brief. -46.33. In the year 2002, what is the difference between the Domestic credit (% of GDP) of Algeria and Domestic credit (% of GDP) of Hungary?
Give a very brief answer. -22.24. In the year 2002, what is the difference between the Domestic credit (% of GDP) of Algeria and Domestic credit (% of GDP) of Moldova?
Provide a short and direct response. -4.98. In the year 2002, what is the difference between the Domestic credit (% of GDP) of Barbados and Domestic credit (% of GDP) of Hungary?
Ensure brevity in your answer.  24.09. In the year 2002, what is the difference between the Domestic credit (% of GDP) in Barbados and Domestic credit (% of GDP) in Moldova?
Ensure brevity in your answer.  41.35. In the year 2002, what is the difference between the Domestic credit (% of GDP) in Hungary and Domestic credit (% of GDP) in Moldova?
Offer a very short reply. 17.26. In the year 2003, what is the difference between the Domestic credit (% of GDP) in Algeria and Domestic credit (% of GDP) in Barbados?
Offer a very short reply. -49.35. In the year 2003, what is the difference between the Domestic credit (% of GDP) in Algeria and Domestic credit (% of GDP) in Hungary?
Provide a succinct answer. -25.33. In the year 2003, what is the difference between the Domestic credit (% of GDP) in Algeria and Domestic credit (% of GDP) in Moldova?
Offer a terse response. -9.1. In the year 2003, what is the difference between the Domestic credit (% of GDP) in Barbados and Domestic credit (% of GDP) in Hungary?
Your answer should be very brief. 24.01. In the year 2003, what is the difference between the Domestic credit (% of GDP) of Barbados and Domestic credit (% of GDP) of Moldova?
Your response must be concise. 40.24. In the year 2003, what is the difference between the Domestic credit (% of GDP) in Hungary and Domestic credit (% of GDP) in Moldova?
Your response must be concise. 16.23. In the year 2004, what is the difference between the Domestic credit (% of GDP) of Algeria and Domestic credit (% of GDP) of Barbados?
Give a very brief answer. -54.55. In the year 2004, what is the difference between the Domestic credit (% of GDP) in Algeria and Domestic credit (% of GDP) in Hungary?
Your response must be concise. -28.06. In the year 2004, what is the difference between the Domestic credit (% of GDP) of Algeria and Domestic credit (% of GDP) of Moldova?
Keep it short and to the point. -10.24. In the year 2004, what is the difference between the Domestic credit (% of GDP) in Barbados and Domestic credit (% of GDP) in Hungary?
Keep it short and to the point. 26.5. In the year 2004, what is the difference between the Domestic credit (% of GDP) in Barbados and Domestic credit (% of GDP) in Moldova?
Provide a short and direct response. 44.31. In the year 2004, what is the difference between the Domestic credit (% of GDP) of Hungary and Domestic credit (% of GDP) of Moldova?
Provide a succinct answer. 17.82. In the year 2005, what is the difference between the Domestic credit (% of GDP) of Algeria and Domestic credit (% of GDP) of Barbados?
Your answer should be compact. -59.14. In the year 2005, what is the difference between the Domestic credit (% of GDP) of Algeria and Domestic credit (% of GDP) of Hungary?
Your response must be concise. -31.57. In the year 2005, what is the difference between the Domestic credit (% of GDP) in Algeria and Domestic credit (% of GDP) in Moldova?
Give a very brief answer. -11.75. In the year 2005, what is the difference between the Domestic credit (% of GDP) in Barbados and Domestic credit (% of GDP) in Hungary?
Give a very brief answer. 27.57. In the year 2005, what is the difference between the Domestic credit (% of GDP) of Barbados and Domestic credit (% of GDP) of Moldova?
Ensure brevity in your answer.  47.38. In the year 2005, what is the difference between the Domestic credit (% of GDP) of Hungary and Domestic credit (% of GDP) of Moldova?
Provide a short and direct response. 19.82. In the year 2006, what is the difference between the Domestic credit (% of GDP) of Algeria and Domestic credit (% of GDP) of Barbados?
Give a very brief answer. -59.87. In the year 2006, what is the difference between the Domestic credit (% of GDP) of Algeria and Domestic credit (% of GDP) of Hungary?
Offer a very short reply. -35.49. In the year 2006, what is the difference between the Domestic credit (% of GDP) of Algeria and Domestic credit (% of GDP) of Moldova?
Your response must be concise. -15.38. In the year 2006, what is the difference between the Domestic credit (% of GDP) in Barbados and Domestic credit (% of GDP) in Hungary?
Your response must be concise. 24.37. In the year 2006, what is the difference between the Domestic credit (% of GDP) in Barbados and Domestic credit (% of GDP) in Moldova?
Your answer should be very brief. 44.49. In the year 2006, what is the difference between the Domestic credit (% of GDP) in Hungary and Domestic credit (% of GDP) in Moldova?
Ensure brevity in your answer.  20.12. In the year 2007, what is the difference between the Domestic credit (% of GDP) of Algeria and Domestic credit (% of GDP) of Barbados?
Provide a short and direct response. -60.18. In the year 2007, what is the difference between the Domestic credit (% of GDP) in Algeria and Domestic credit (% of GDP) in Hungary?
Your response must be concise. -40.58. In the year 2007, what is the difference between the Domestic credit (% of GDP) in Algeria and Domestic credit (% of GDP) in Moldova?
Your answer should be compact. -23.88. In the year 2007, what is the difference between the Domestic credit (% of GDP) of Barbados and Domestic credit (% of GDP) of Hungary?
Your answer should be very brief. 19.59. In the year 2007, what is the difference between the Domestic credit (% of GDP) of Barbados and Domestic credit (% of GDP) of Moldova?
Keep it short and to the point. 36.3. In the year 2007, what is the difference between the Domestic credit (% of GDP) of Hungary and Domestic credit (% of GDP) of Moldova?
Your answer should be very brief. 16.71. In the year 2008, what is the difference between the Domestic credit (% of GDP) in Algeria and Domestic credit (% of GDP) in Barbados?
Your answer should be very brief. -65.79. In the year 2008, what is the difference between the Domestic credit (% of GDP) in Algeria and Domestic credit (% of GDP) in Hungary?
Keep it short and to the point. -46.97. In the year 2008, what is the difference between the Domestic credit (% of GDP) in Algeria and Domestic credit (% of GDP) in Moldova?
Provide a succinct answer. -23.67. In the year 2008, what is the difference between the Domestic credit (% of GDP) of Barbados and Domestic credit (% of GDP) of Hungary?
Make the answer very short. 18.82. In the year 2008, what is the difference between the Domestic credit (% of GDP) in Barbados and Domestic credit (% of GDP) in Moldova?
Provide a short and direct response. 42.12. In the year 2008, what is the difference between the Domestic credit (% of GDP) of Hungary and Domestic credit (% of GDP) of Moldova?
Your answer should be very brief. 23.3. In the year 2009, what is the difference between the Domestic credit (% of GDP) in Algeria and Domestic credit (% of GDP) in Barbados?
Offer a very short reply. -63.92. In the year 2009, what is the difference between the Domestic credit (% of GDP) of Algeria and Domestic credit (% of GDP) of Hungary?
Your answer should be very brief. -44.1. In the year 2009, what is the difference between the Domestic credit (% of GDP) in Algeria and Domestic credit (% of GDP) in Moldova?
Ensure brevity in your answer.  -19.75. In the year 2009, what is the difference between the Domestic credit (% of GDP) in Barbados and Domestic credit (% of GDP) in Hungary?
Keep it short and to the point. 19.82. In the year 2009, what is the difference between the Domestic credit (% of GDP) of Barbados and Domestic credit (% of GDP) of Moldova?
Your response must be concise. 44.17. In the year 2009, what is the difference between the Domestic credit (% of GDP) of Hungary and Domestic credit (% of GDP) of Moldova?
Ensure brevity in your answer.  24.35. What is the ratio of the Domestic credit (% of GDP) of Algeria in 2002 to that in 2003?
Provide a succinct answer. 1.09. What is the ratio of the Domestic credit (% of GDP) in Barbados in 2002 to that in 2003?
Offer a terse response. 0.97. What is the ratio of the Domestic credit (% of GDP) in Hungary in 2002 to that in 2003?
Your response must be concise. 0.94. What is the ratio of the Domestic credit (% of GDP) in Moldova in 2002 to that in 2003?
Ensure brevity in your answer.  0.84. What is the ratio of the Domestic credit (% of GDP) of Algeria in 2002 to that in 2004?
Make the answer very short. 1.11. What is the ratio of the Domestic credit (% of GDP) of Barbados in 2002 to that in 2004?
Ensure brevity in your answer.  0.89. What is the ratio of the Domestic credit (% of GDP) in Hungary in 2002 to that in 2004?
Give a very brief answer. 0.88. What is the ratio of the Domestic credit (% of GDP) of Moldova in 2002 to that in 2004?
Your answer should be compact. 0.81. What is the ratio of the Domestic credit (% of GDP) of Algeria in 2002 to that in 2005?
Your answer should be very brief. 1.03. What is the ratio of the Domestic credit (% of GDP) of Barbados in 2002 to that in 2005?
Provide a short and direct response. 0.82. What is the ratio of the Domestic credit (% of GDP) of Hungary in 2002 to that in 2005?
Make the answer very short. 0.79. What is the ratio of the Domestic credit (% of GDP) of Moldova in 2002 to that in 2005?
Your answer should be compact. 0.73. What is the ratio of the Domestic credit (% of GDP) in Algeria in 2002 to that in 2006?
Make the answer very short. 1.01. What is the ratio of the Domestic credit (% of GDP) in Barbados in 2002 to that in 2006?
Provide a succinct answer. 0.81. What is the ratio of the Domestic credit (% of GDP) in Hungary in 2002 to that in 2006?
Offer a very short reply. 0.72. What is the ratio of the Domestic credit (% of GDP) in Moldova in 2002 to that in 2006?
Offer a very short reply. 0.62. What is the ratio of the Domestic credit (% of GDP) of Algeria in 2002 to that in 2007?
Offer a terse response. 0.94. What is the ratio of the Domestic credit (% of GDP) of Barbados in 2002 to that in 2007?
Keep it short and to the point. 0.8. What is the ratio of the Domestic credit (% of GDP) in Hungary in 2002 to that in 2007?
Your response must be concise. 0.64. What is the ratio of the Domestic credit (% of GDP) in Moldova in 2002 to that in 2007?
Your answer should be very brief. 0.47. What is the ratio of the Domestic credit (% of GDP) in Algeria in 2002 to that in 2008?
Give a very brief answer. 0.95. What is the ratio of the Domestic credit (% of GDP) in Barbados in 2002 to that in 2008?
Your answer should be compact. 0.74. What is the ratio of the Domestic credit (% of GDP) of Hungary in 2002 to that in 2008?
Make the answer very short. 0.58. What is the ratio of the Domestic credit (% of GDP) of Moldova in 2002 to that in 2008?
Make the answer very short. 0.47. What is the ratio of the Domestic credit (% of GDP) of Algeria in 2002 to that in 2009?
Your answer should be very brief. 0.75. What is the ratio of the Domestic credit (% of GDP) in Barbados in 2002 to that in 2009?
Provide a short and direct response. 0.73. What is the ratio of the Domestic credit (% of GDP) of Hungary in 2002 to that in 2009?
Make the answer very short. 0.57. What is the ratio of the Domestic credit (% of GDP) of Moldova in 2002 to that in 2009?
Your answer should be compact. 0.48. What is the ratio of the Domestic credit (% of GDP) in Algeria in 2003 to that in 2004?
Offer a very short reply. 1.02. What is the ratio of the Domestic credit (% of GDP) in Barbados in 2003 to that in 2004?
Your answer should be very brief. 0.92. What is the ratio of the Domestic credit (% of GDP) of Hungary in 2003 to that in 2004?
Provide a short and direct response. 0.94. What is the ratio of the Domestic credit (% of GDP) of Moldova in 2003 to that in 2004?
Your response must be concise. 0.96. What is the ratio of the Domestic credit (% of GDP) in Algeria in 2003 to that in 2005?
Give a very brief answer. 0.94. What is the ratio of the Domestic credit (% of GDP) in Barbados in 2003 to that in 2005?
Give a very brief answer. 0.85. What is the ratio of the Domestic credit (% of GDP) of Hungary in 2003 to that in 2005?
Your answer should be very brief. 0.84. What is the ratio of the Domestic credit (% of GDP) of Moldova in 2003 to that in 2005?
Your response must be concise. 0.86. What is the ratio of the Domestic credit (% of GDP) in Algeria in 2003 to that in 2006?
Your answer should be very brief. 0.93. What is the ratio of the Domestic credit (% of GDP) of Barbados in 2003 to that in 2006?
Your response must be concise. 0.84. What is the ratio of the Domestic credit (% of GDP) of Hungary in 2003 to that in 2006?
Provide a short and direct response. 0.77. What is the ratio of the Domestic credit (% of GDP) in Moldova in 2003 to that in 2006?
Give a very brief answer. 0.74. What is the ratio of the Domestic credit (% of GDP) in Algeria in 2003 to that in 2007?
Your answer should be very brief. 0.86. What is the ratio of the Domestic credit (% of GDP) of Barbados in 2003 to that in 2007?
Provide a short and direct response. 0.83. What is the ratio of the Domestic credit (% of GDP) of Hungary in 2003 to that in 2007?
Keep it short and to the point. 0.68. What is the ratio of the Domestic credit (% of GDP) of Moldova in 2003 to that in 2007?
Your answer should be very brief. 0.55. What is the ratio of the Domestic credit (% of GDP) in Algeria in 2003 to that in 2008?
Give a very brief answer. 0.88. What is the ratio of the Domestic credit (% of GDP) of Barbados in 2003 to that in 2008?
Your response must be concise. 0.77. What is the ratio of the Domestic credit (% of GDP) of Hungary in 2003 to that in 2008?
Your answer should be compact. 0.61. What is the ratio of the Domestic credit (% of GDP) of Moldova in 2003 to that in 2008?
Provide a short and direct response. 0.56. What is the ratio of the Domestic credit (% of GDP) of Algeria in 2003 to that in 2009?
Offer a terse response. 0.69. What is the ratio of the Domestic credit (% of GDP) in Barbados in 2003 to that in 2009?
Your answer should be compact. 0.76. What is the ratio of the Domestic credit (% of GDP) of Hungary in 2003 to that in 2009?
Provide a succinct answer. 0.61. What is the ratio of the Domestic credit (% of GDP) of Moldova in 2003 to that in 2009?
Ensure brevity in your answer.  0.56. What is the ratio of the Domestic credit (% of GDP) in Algeria in 2004 to that in 2005?
Keep it short and to the point. 0.93. What is the ratio of the Domestic credit (% of GDP) of Barbados in 2004 to that in 2005?
Your response must be concise. 0.92. What is the ratio of the Domestic credit (% of GDP) of Hungary in 2004 to that in 2005?
Give a very brief answer. 0.9. What is the ratio of the Domestic credit (% of GDP) in Moldova in 2004 to that in 2005?
Provide a succinct answer. 0.9. What is the ratio of the Domestic credit (% of GDP) of Algeria in 2004 to that in 2006?
Your response must be concise. 0.91. What is the ratio of the Domestic credit (% of GDP) in Barbados in 2004 to that in 2006?
Provide a short and direct response. 0.91. What is the ratio of the Domestic credit (% of GDP) of Hungary in 2004 to that in 2006?
Offer a terse response. 0.82. What is the ratio of the Domestic credit (% of GDP) of Moldova in 2004 to that in 2006?
Provide a succinct answer. 0.77. What is the ratio of the Domestic credit (% of GDP) of Algeria in 2004 to that in 2007?
Your response must be concise. 0.85. What is the ratio of the Domestic credit (% of GDP) of Barbados in 2004 to that in 2007?
Provide a succinct answer. 0.9. What is the ratio of the Domestic credit (% of GDP) in Hungary in 2004 to that in 2007?
Make the answer very short. 0.73. What is the ratio of the Domestic credit (% of GDP) in Moldova in 2004 to that in 2007?
Provide a short and direct response. 0.58. What is the ratio of the Domestic credit (% of GDP) in Algeria in 2004 to that in 2008?
Give a very brief answer. 0.86. What is the ratio of the Domestic credit (% of GDP) of Barbados in 2004 to that in 2008?
Offer a very short reply. 0.83. What is the ratio of the Domestic credit (% of GDP) in Hungary in 2004 to that in 2008?
Offer a terse response. 0.65. What is the ratio of the Domestic credit (% of GDP) of Moldova in 2004 to that in 2008?
Offer a terse response. 0.58. What is the ratio of the Domestic credit (% of GDP) in Algeria in 2004 to that in 2009?
Ensure brevity in your answer.  0.68. What is the ratio of the Domestic credit (% of GDP) of Barbados in 2004 to that in 2009?
Your response must be concise. 0.82. What is the ratio of the Domestic credit (% of GDP) of Hungary in 2004 to that in 2009?
Your answer should be compact. 0.65. What is the ratio of the Domestic credit (% of GDP) of Moldova in 2004 to that in 2009?
Your response must be concise. 0.59. What is the ratio of the Domestic credit (% of GDP) of Algeria in 2005 to that in 2006?
Keep it short and to the point. 0.98. What is the ratio of the Domestic credit (% of GDP) in Barbados in 2005 to that in 2006?
Offer a very short reply. 0.99. What is the ratio of the Domestic credit (% of GDP) of Hungary in 2005 to that in 2006?
Make the answer very short. 0.91. What is the ratio of the Domestic credit (% of GDP) in Moldova in 2005 to that in 2006?
Give a very brief answer. 0.86. What is the ratio of the Domestic credit (% of GDP) of Algeria in 2005 to that in 2007?
Your response must be concise. 0.91. What is the ratio of the Domestic credit (% of GDP) of Barbados in 2005 to that in 2007?
Offer a terse response. 0.97. What is the ratio of the Domestic credit (% of GDP) in Hungary in 2005 to that in 2007?
Provide a succinct answer. 0.81. What is the ratio of the Domestic credit (% of GDP) in Moldova in 2005 to that in 2007?
Keep it short and to the point. 0.64. What is the ratio of the Domestic credit (% of GDP) in Algeria in 2005 to that in 2008?
Your answer should be compact. 0.93. What is the ratio of the Domestic credit (% of GDP) in Barbados in 2005 to that in 2008?
Keep it short and to the point. 0.9. What is the ratio of the Domestic credit (% of GDP) of Hungary in 2005 to that in 2008?
Keep it short and to the point. 0.73. What is the ratio of the Domestic credit (% of GDP) in Moldova in 2005 to that in 2008?
Give a very brief answer. 0.65. What is the ratio of the Domestic credit (% of GDP) of Algeria in 2005 to that in 2009?
Give a very brief answer. 0.73. What is the ratio of the Domestic credit (% of GDP) of Barbados in 2005 to that in 2009?
Your answer should be very brief. 0.89. What is the ratio of the Domestic credit (% of GDP) of Hungary in 2005 to that in 2009?
Keep it short and to the point. 0.72. What is the ratio of the Domestic credit (% of GDP) in Moldova in 2005 to that in 2009?
Provide a succinct answer. 0.66. What is the ratio of the Domestic credit (% of GDP) in Algeria in 2006 to that in 2007?
Make the answer very short. 0.93. What is the ratio of the Domestic credit (% of GDP) in Barbados in 2006 to that in 2007?
Your response must be concise. 0.98. What is the ratio of the Domestic credit (% of GDP) in Hungary in 2006 to that in 2007?
Make the answer very short. 0.89. What is the ratio of the Domestic credit (% of GDP) in Moldova in 2006 to that in 2007?
Offer a terse response. 0.75. What is the ratio of the Domestic credit (% of GDP) in Algeria in 2006 to that in 2008?
Give a very brief answer. 0.95. What is the ratio of the Domestic credit (% of GDP) of Barbados in 2006 to that in 2008?
Provide a short and direct response. 0.92. What is the ratio of the Domestic credit (% of GDP) in Hungary in 2006 to that in 2008?
Keep it short and to the point. 0.8. What is the ratio of the Domestic credit (% of GDP) of Moldova in 2006 to that in 2008?
Give a very brief answer. 0.75. What is the ratio of the Domestic credit (% of GDP) of Algeria in 2006 to that in 2009?
Offer a terse response. 0.74. What is the ratio of the Domestic credit (% of GDP) in Barbados in 2006 to that in 2009?
Provide a short and direct response. 0.9. What is the ratio of the Domestic credit (% of GDP) in Hungary in 2006 to that in 2009?
Make the answer very short. 0.79. What is the ratio of the Domestic credit (% of GDP) in Moldova in 2006 to that in 2009?
Make the answer very short. 0.76. What is the ratio of the Domestic credit (% of GDP) in Barbados in 2007 to that in 2008?
Provide a short and direct response. 0.93. What is the ratio of the Domestic credit (% of GDP) of Hungary in 2007 to that in 2008?
Your response must be concise. 0.9. What is the ratio of the Domestic credit (% of GDP) of Moldova in 2007 to that in 2008?
Your answer should be very brief. 1.01. What is the ratio of the Domestic credit (% of GDP) of Algeria in 2007 to that in 2009?
Give a very brief answer. 0.8. What is the ratio of the Domestic credit (% of GDP) in Barbados in 2007 to that in 2009?
Provide a short and direct response. 0.91. What is the ratio of the Domestic credit (% of GDP) in Hungary in 2007 to that in 2009?
Make the answer very short. 0.89. What is the ratio of the Domestic credit (% of GDP) of Moldova in 2007 to that in 2009?
Your response must be concise. 1.02. What is the ratio of the Domestic credit (% of GDP) in Algeria in 2008 to that in 2009?
Provide a succinct answer. 0.79. What is the ratio of the Domestic credit (% of GDP) in Barbados in 2008 to that in 2009?
Make the answer very short. 0.98. What is the ratio of the Domestic credit (% of GDP) of Hungary in 2008 to that in 2009?
Ensure brevity in your answer.  0.99. What is the ratio of the Domestic credit (% of GDP) of Moldova in 2008 to that in 2009?
Offer a very short reply. 1.01. What is the difference between the highest and the second highest Domestic credit (% of GDP) in Algeria?
Give a very brief answer. 3.28. What is the difference between the highest and the second highest Domestic credit (% of GDP) in Barbados?
Provide a succinct answer. 1.59. What is the difference between the highest and the second highest Domestic credit (% of GDP) of Hungary?
Offer a very short reply. 0.59. What is the difference between the highest and the second highest Domestic credit (% of GDP) in Moldova?
Keep it short and to the point. 0.4. What is the difference between the highest and the lowest Domestic credit (% of GDP) in Algeria?
Provide a succinct answer. 5.27. What is the difference between the highest and the lowest Domestic credit (% of GDP) of Barbados?
Your response must be concise. 21.67. What is the difference between the highest and the lowest Domestic credit (% of GDP) of Hungary?
Your response must be concise. 25.94. What is the difference between the highest and the lowest Domestic credit (% of GDP) of Moldova?
Provide a succinct answer. 19.7. 